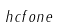Convert formula to latex. <formula><loc_0><loc_0><loc_500><loc_500>\ h c f o n e</formula> 